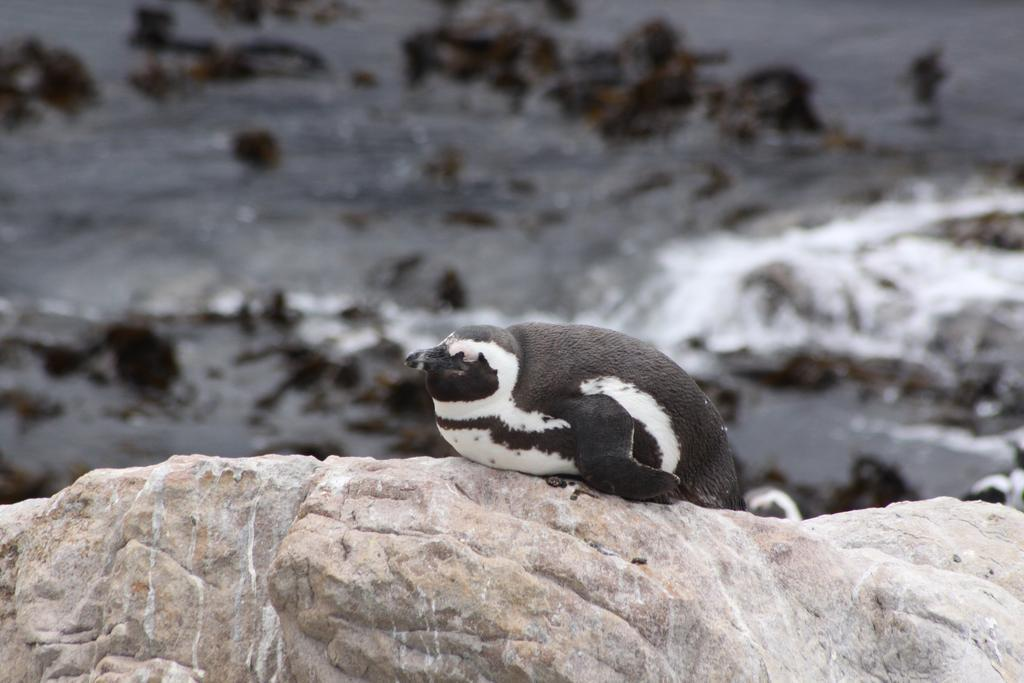What animal is present in the image? There is a penguin in the image. Where is the penguin located? The penguin is on a rock. Can you describe the background of the image? The background of the image is blurred. What type of growth can be seen on the penguin in the image? There is no growth visible on the penguin in the image. Is there a swing present in the image? There is no swing present in the image. 